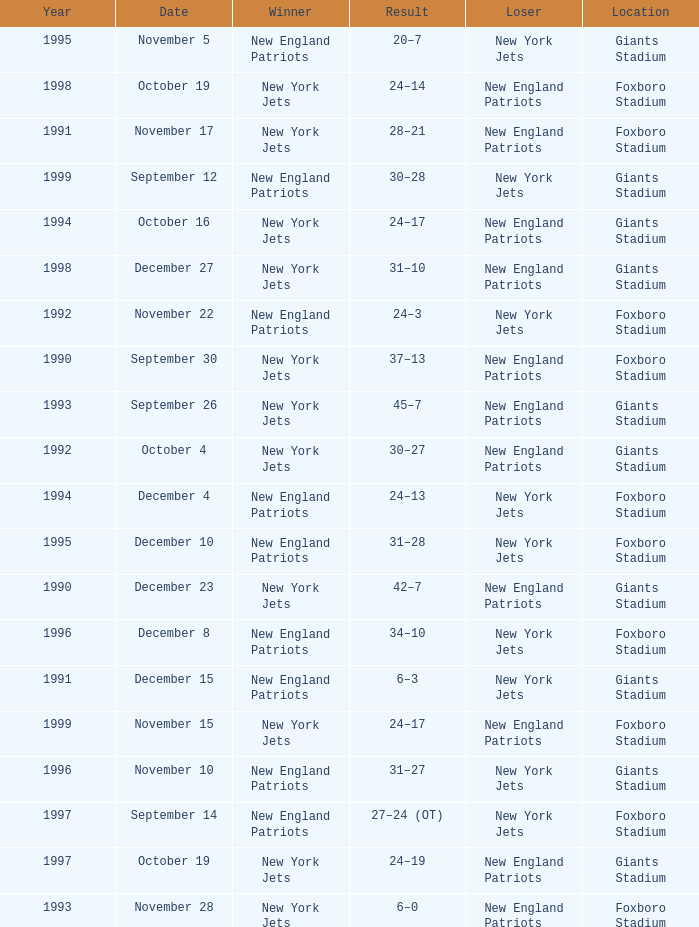What is the year when the Winner was the new york jets, with a Result of 24–17, played at giants stadium? 1994.0. 